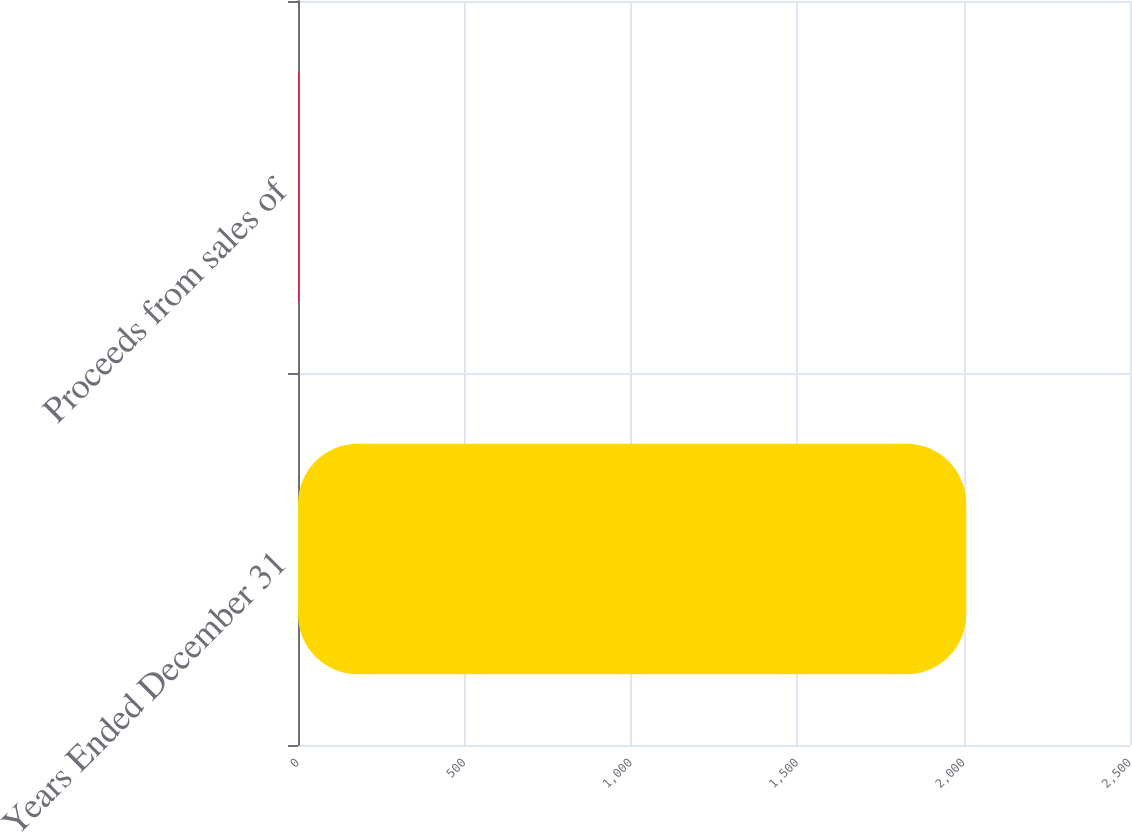Convert chart. <chart><loc_0><loc_0><loc_500><loc_500><bar_chart><fcel>Years Ended December 31<fcel>Proceeds from sales of<nl><fcel>2008<fcel>2<nl></chart> 